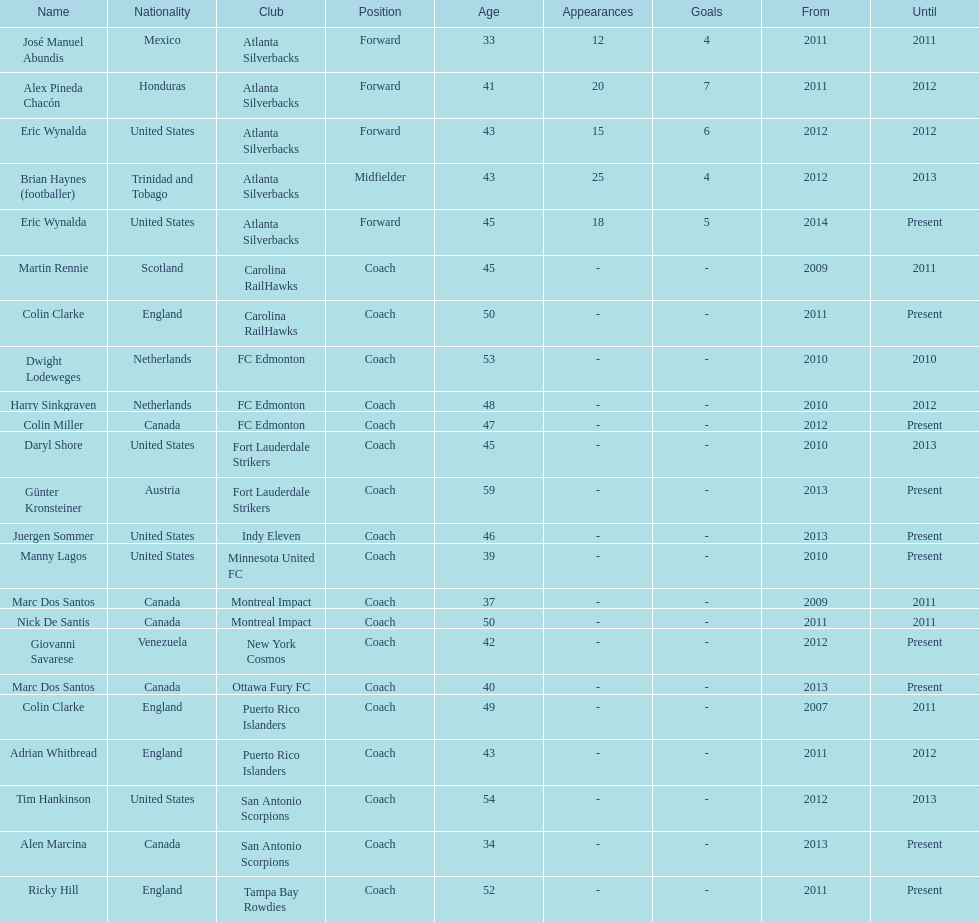What year did marc dos santos start as coach? 2009. Which other starting years correspond with this year? 2009. Who was the other coach with this starting year Martin Rennie. 